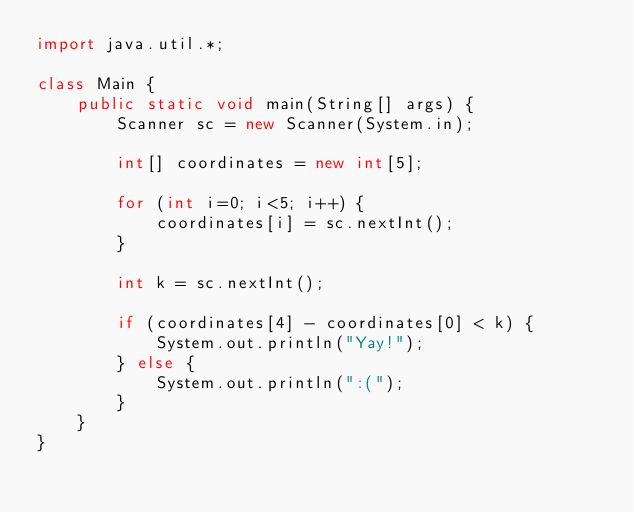<code> <loc_0><loc_0><loc_500><loc_500><_Java_>import java.util.*;

class Main {
    public static void main(String[] args) {
        Scanner sc = new Scanner(System.in);

        int[] coordinates = new int[5];

        for (int i=0; i<5; i++) {
            coordinates[i] = sc.nextInt();
        }

        int k = sc.nextInt();

        if (coordinates[4] - coordinates[0] < k) {
            System.out.println("Yay!");
        } else {
            System.out.println(":(");
        }
    }
}
</code> 